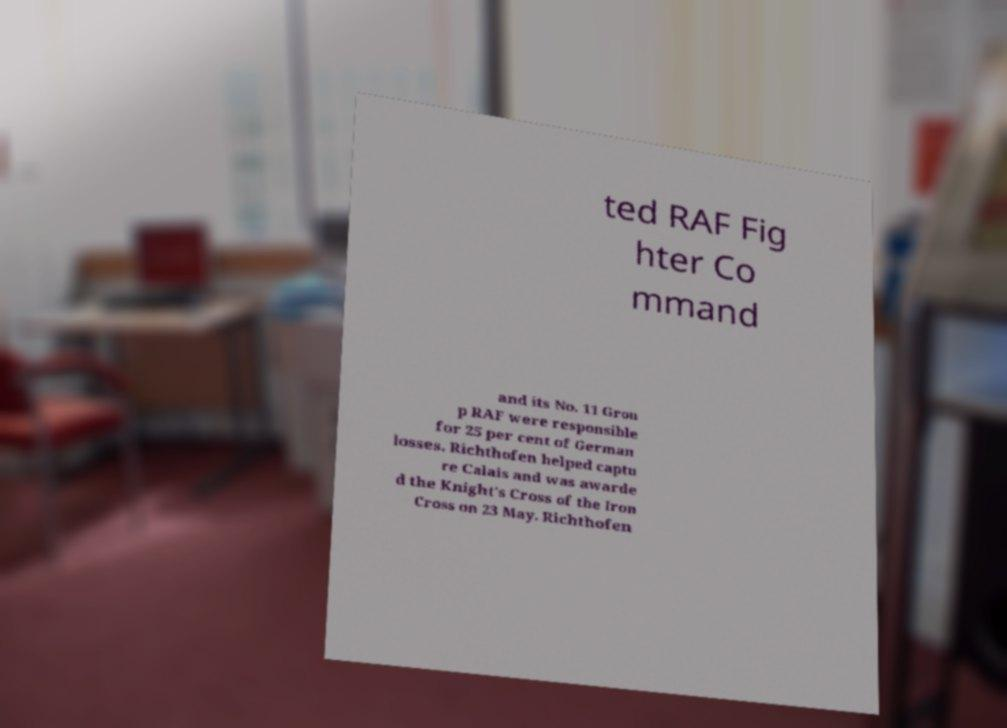For documentation purposes, I need the text within this image transcribed. Could you provide that? ted RAF Fig hter Co mmand and its No. 11 Grou p RAF were responsible for 25 per cent of German losses. Richthofen helped captu re Calais and was awarde d the Knight's Cross of the Iron Cross on 23 May. Richthofen 